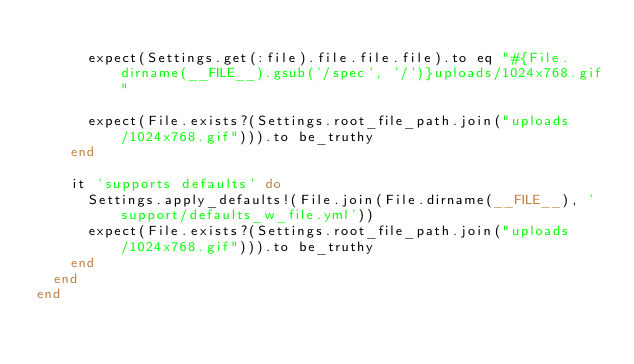<code> <loc_0><loc_0><loc_500><loc_500><_Ruby_>
      expect(Settings.get(:file).file.file.file).to eq "#{File.dirname(__FILE__).gsub('/spec', '/')}uploads/1024x768.gif"

      expect(File.exists?(Settings.root_file_path.join("uploads/1024x768.gif"))).to be_truthy
    end

    it 'supports defaults' do
      Settings.apply_defaults!(File.join(File.dirname(__FILE__), 'support/defaults_w_file.yml'))
      expect(File.exists?(Settings.root_file_path.join("uploads/1024x768.gif"))).to be_truthy
    end
  end
end

</code> 